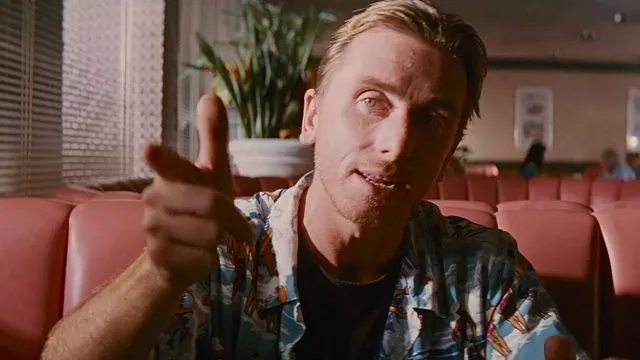Can you describe the fashion style depicted in the image? Certainly. The person in the image is wearing a patterned, short-sleeved shirt that features a bright, tropical design. This style is often associated with leisure and vacation settings and conveys a relaxed and easy-going persona. The sleeves rolled up to the elbows further emphasize a carefree attitude and comfort. 